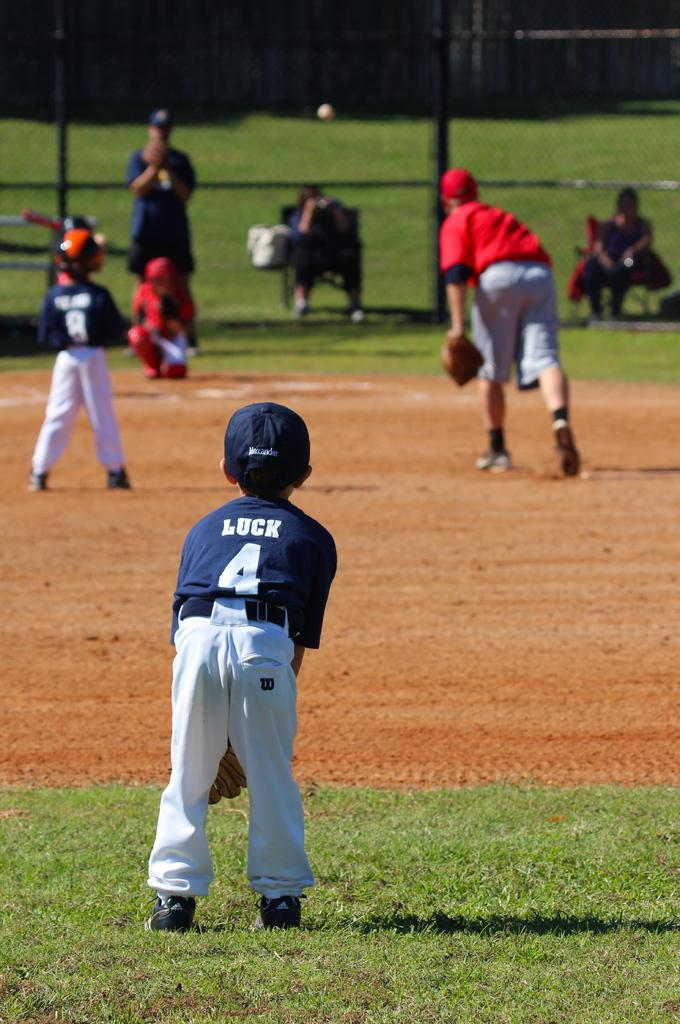<image>
Create a compact narrative representing the image presented. A kid playing baseball has the number 4 in his jersey. 